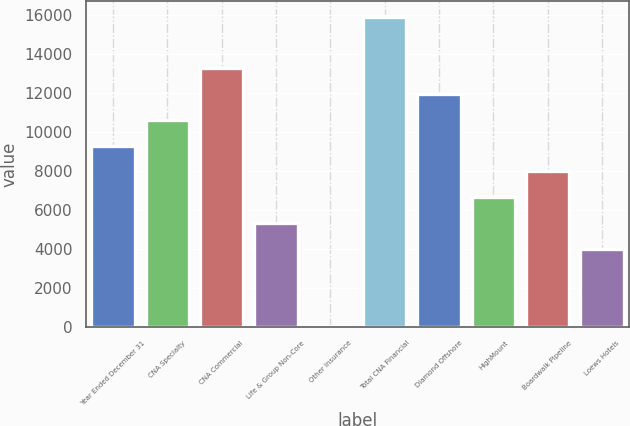<chart> <loc_0><loc_0><loc_500><loc_500><bar_chart><fcel>Year Ended December 31<fcel>CNA Specialty<fcel>CNA Commercial<fcel>Life & Group Non-Core<fcel>Other Insurance<fcel>Total CNA Financial<fcel>Diamond Offshore<fcel>HighMount<fcel>Boardwalk Pipeline<fcel>Loews Hotels<nl><fcel>9281.6<fcel>10603.4<fcel>13247<fcel>5316.2<fcel>29<fcel>15890.6<fcel>11925.2<fcel>6638<fcel>7959.8<fcel>3994.4<nl></chart> 